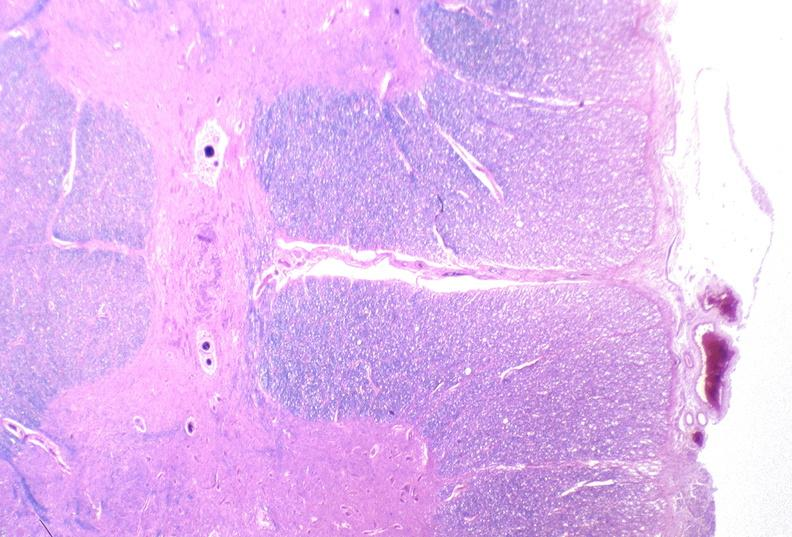why does this image show spinal cord injury?
Answer the question using a single word or phrase. Due to vertebral column trauma 